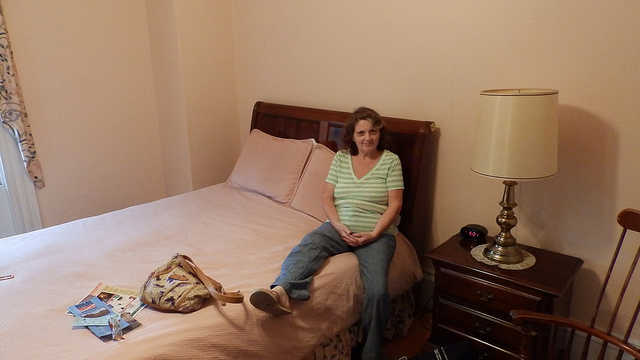What pattern is on the blanket? The blanket on the bed displays a leopard print pattern, which is quite distinctive and adds a unique touch to the room's decor. 